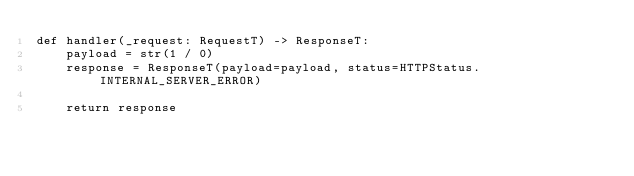Convert code to text. <code><loc_0><loc_0><loc_500><loc_500><_Python_>def handler(_request: RequestT) -> ResponseT:
    payload = str(1 / 0)
    response = ResponseT(payload=payload, status=HTTPStatus.INTERNAL_SERVER_ERROR)

    return response
</code> 